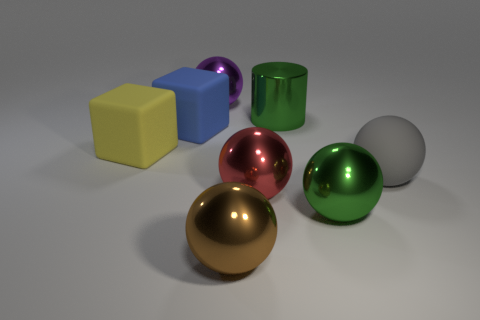Subtract all purple balls. How many balls are left? 4 Subtract 2 balls. How many balls are left? 3 Subtract all big rubber balls. How many balls are left? 4 Subtract all yellow spheres. Subtract all gray cubes. How many spheres are left? 5 Add 2 small purple matte objects. How many objects exist? 10 Subtract all spheres. How many objects are left? 3 Subtract all big purple matte balls. Subtract all big blue things. How many objects are left? 7 Add 1 blue cubes. How many blue cubes are left? 2 Add 5 big purple metal spheres. How many big purple metal spheres exist? 6 Subtract 0 red cylinders. How many objects are left? 8 